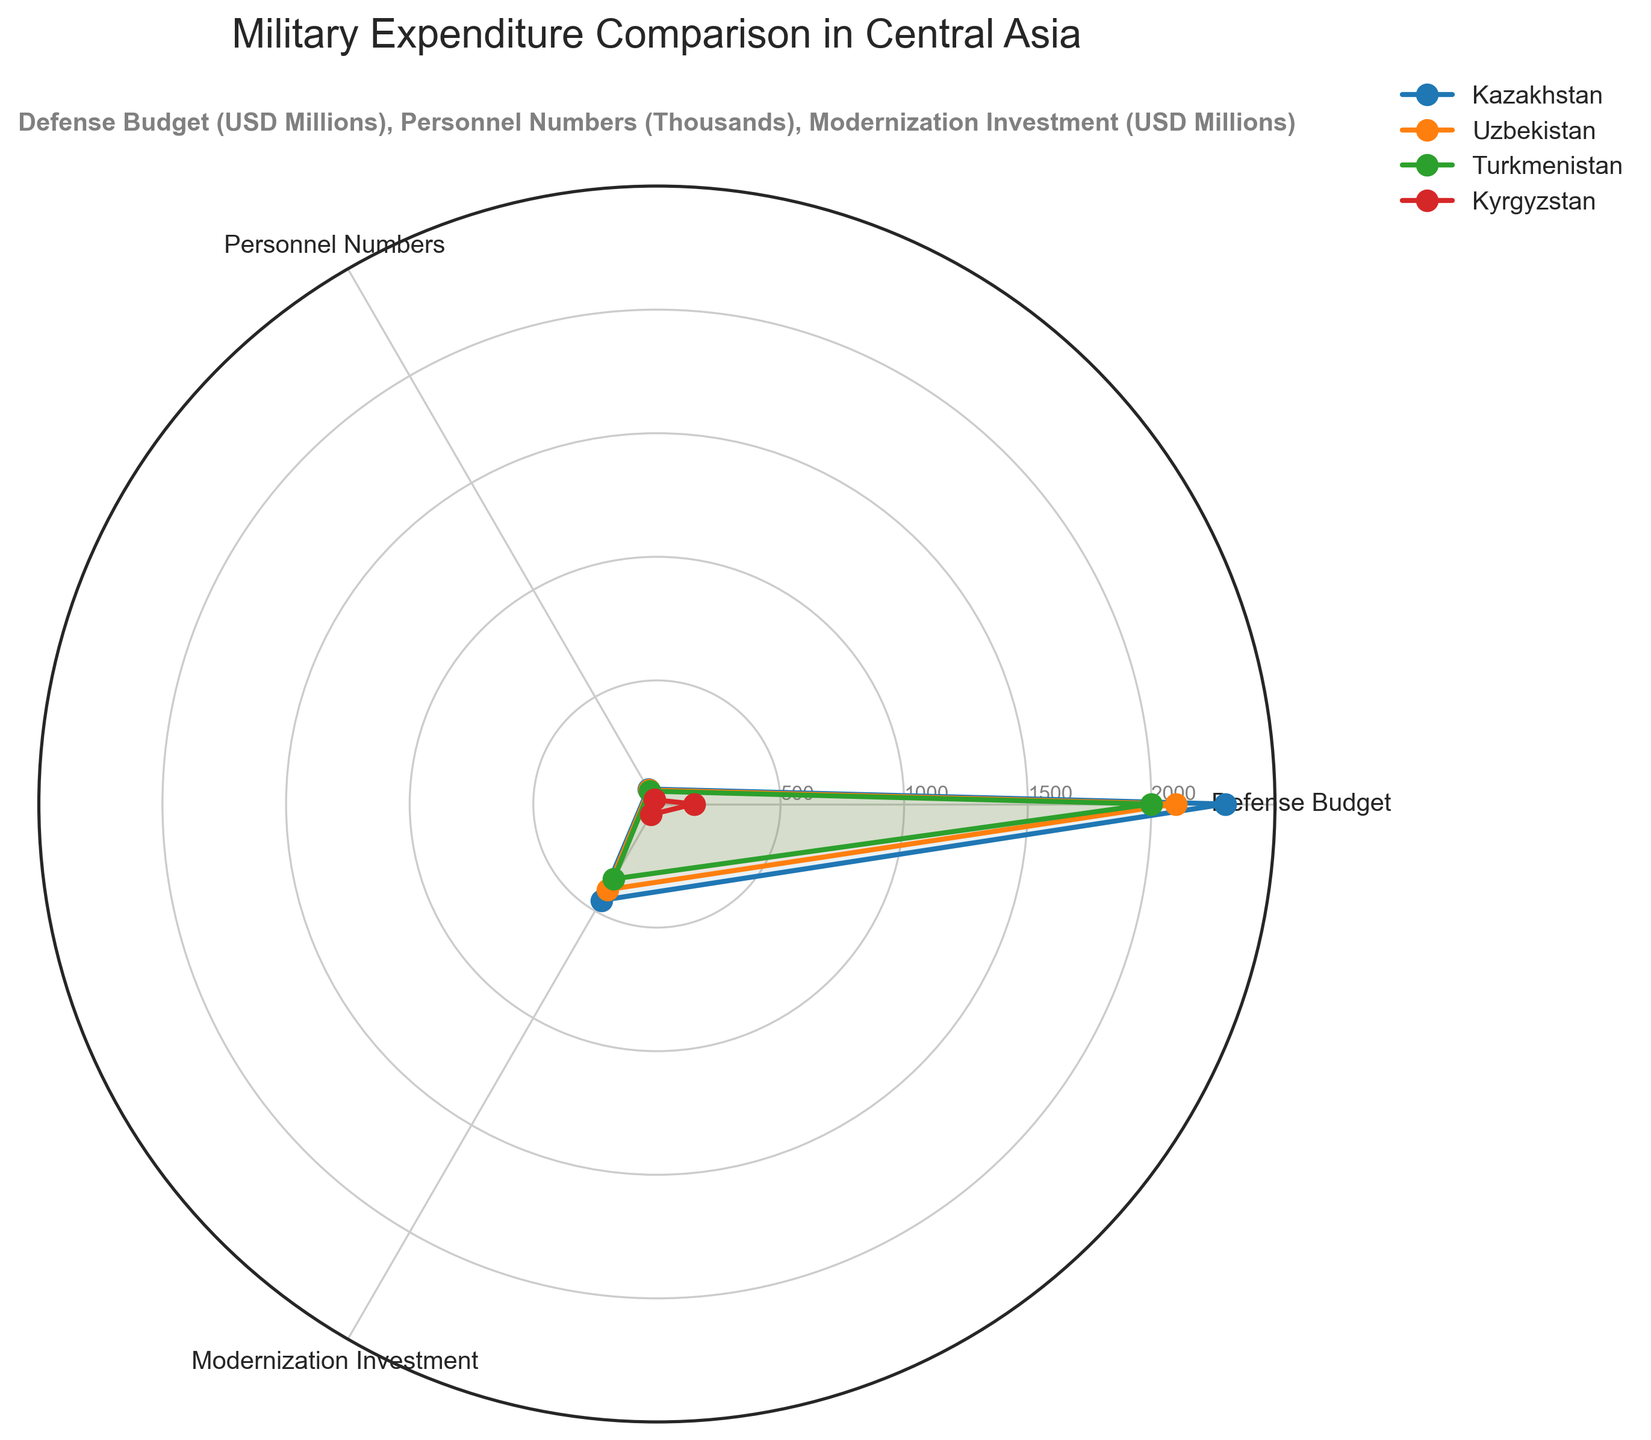What's the title of the radar chart? The title is located at the top of the chart and usually summarises the content of the chart. Here, it indicates the comparison of military expenditures among the Central Asian countries.
Answer: Military Expenditure Comparison in Central Asia What are the categories being compared in the radar chart? The category labels are found around the chart and indicate the aspects of military expenditure being visualized.
Answer: Defense Budget, Personnel Numbers, Modernization Investment Which country has the highest values in all categories? By examining the outlines and the filled areas of the radar chart, one can identify the largest values extending farthest in all categories. Kazakhstan consistently shows the largest values in each sector.
Answer: Kazakhstan How does Kyrgyzstan's Defense Budget compare to Uzbekistan's? Comparing the Defense Budget values on the radar chart, Kyrgyzstan's value is significantly closer to the center, indicating a much smaller budget compared to Uzbekistan’s.
Answer: Kyrgyzstan's Defense Budget is much smaller than Uzbekistan's Rank the countries based on their Personnel Numbers. To rank the countries by Personnel Numbers, observe the specific label and note the values indicated by their position on the corresponding axis. Kazakhstan has the highest, followed by Uzbekistan, then Turkmenistan, and finally Kyrgyzstan.
Answer: Kazakhstan, Uzbekistan, Turkmenistan, Kyrgyzstan Which country has the smallest Modernization Investment? Look at the Modernization Investment values around the radar chart. The country with the shortest distance from the center in this category represents the smallest investment.
Answer: Kyrgyzstan What is the range of Defense Budgets among the countries? The range is determined by finding the difference between the highest and lowest Defense Budget values on the chart. Kazakhstan has the highest at 2300 million, and Kyrgyzstan has the lowest at 150 million, so the range is 2300 - 150.
Answer: 2150 million USD How does the Modernization Investment in Turkmenistan compare to Kazakhstan? Compare the lengths of the Modernization Investment axis for Turkmenistan and Kazakhstan. Turkmenistan's value reaches 350 million, while Kazakhstan’s is at 450 million.
Answer: Turkmenistan's Modernization Investment is less than Kazakhstan's Identify the country with the most balanced expenditure across all categories. A balanced expenditure profile will be reflected by a radar chart shape that is more symmetrical and equally extended in all directions. Turkmenistan appears the most balanced across Defense Budget, Personnel Numbers, and Modernization Investment.
Answer: Turkmenistan Which country has the greatest disparity between Defense Budget and Personnel Numbers? The disparity is measured by the visual gap between the Defense Budget and Personnel Numbers axes for each country. Kazakhstan shows the largest disparity as its Defense Budget is vastly higher compared to its Personnel Numbers.
Answer: Kazakhstan 